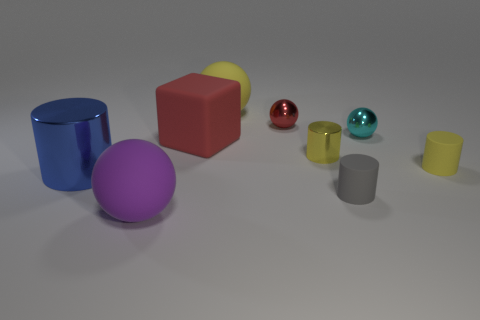How many blue objects have the same size as the purple ball?
Give a very brief answer. 1. Is the large cylinder the same color as the block?
Offer a very short reply. No. Do the big ball behind the large blue cylinder and the red thing behind the block have the same material?
Provide a short and direct response. No. Are there more tiny cyan metallic objects than big rubber balls?
Your answer should be very brief. No. Is there any other thing of the same color as the tiny metal cylinder?
Provide a succinct answer. Yes. Does the large block have the same material as the large cylinder?
Offer a very short reply. No. Are there fewer brown rubber things than tiny red balls?
Offer a terse response. Yes. Is the red metallic thing the same shape as the purple object?
Ensure brevity in your answer.  Yes. The big cylinder has what color?
Offer a terse response. Blue. What number of other objects are there of the same material as the purple thing?
Your answer should be compact. 4. 